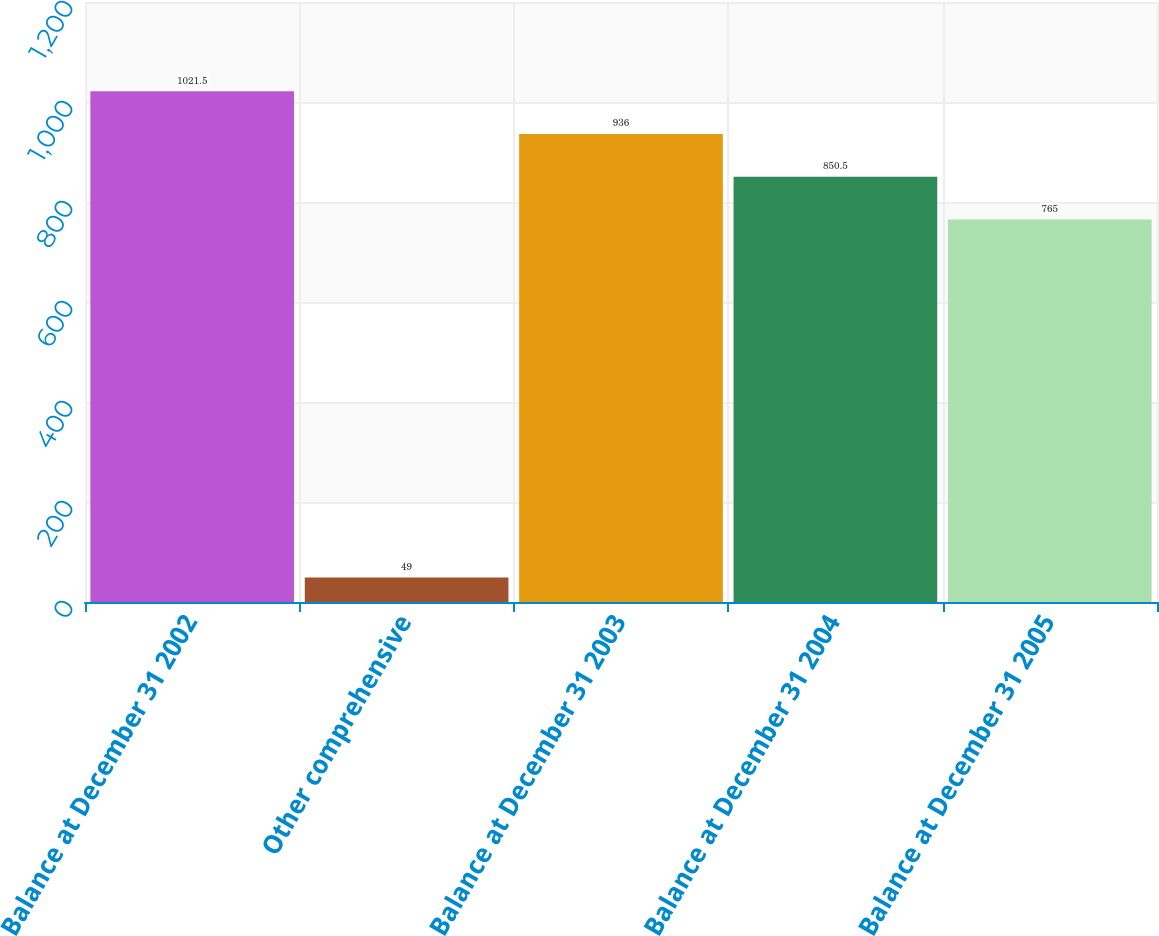Convert chart to OTSL. <chart><loc_0><loc_0><loc_500><loc_500><bar_chart><fcel>Balance at December 31 2002<fcel>Other comprehensive<fcel>Balance at December 31 2003<fcel>Balance at December 31 2004<fcel>Balance at December 31 2005<nl><fcel>1021.5<fcel>49<fcel>936<fcel>850.5<fcel>765<nl></chart> 